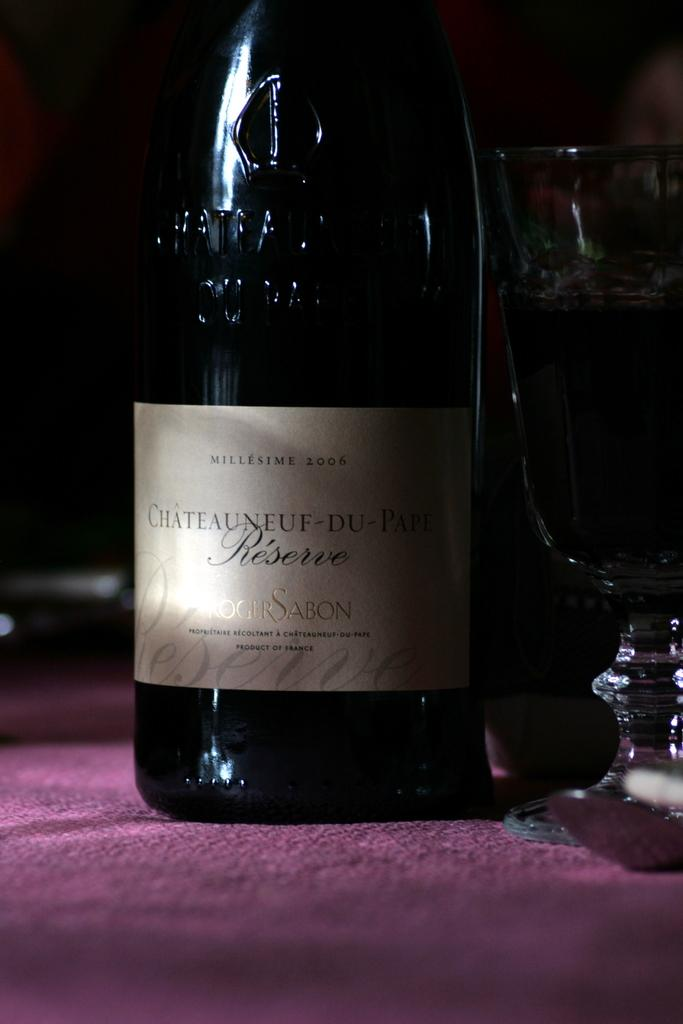Provide a one-sentence caption for the provided image. Wine bottle with a label that syas "SABON" on it. 